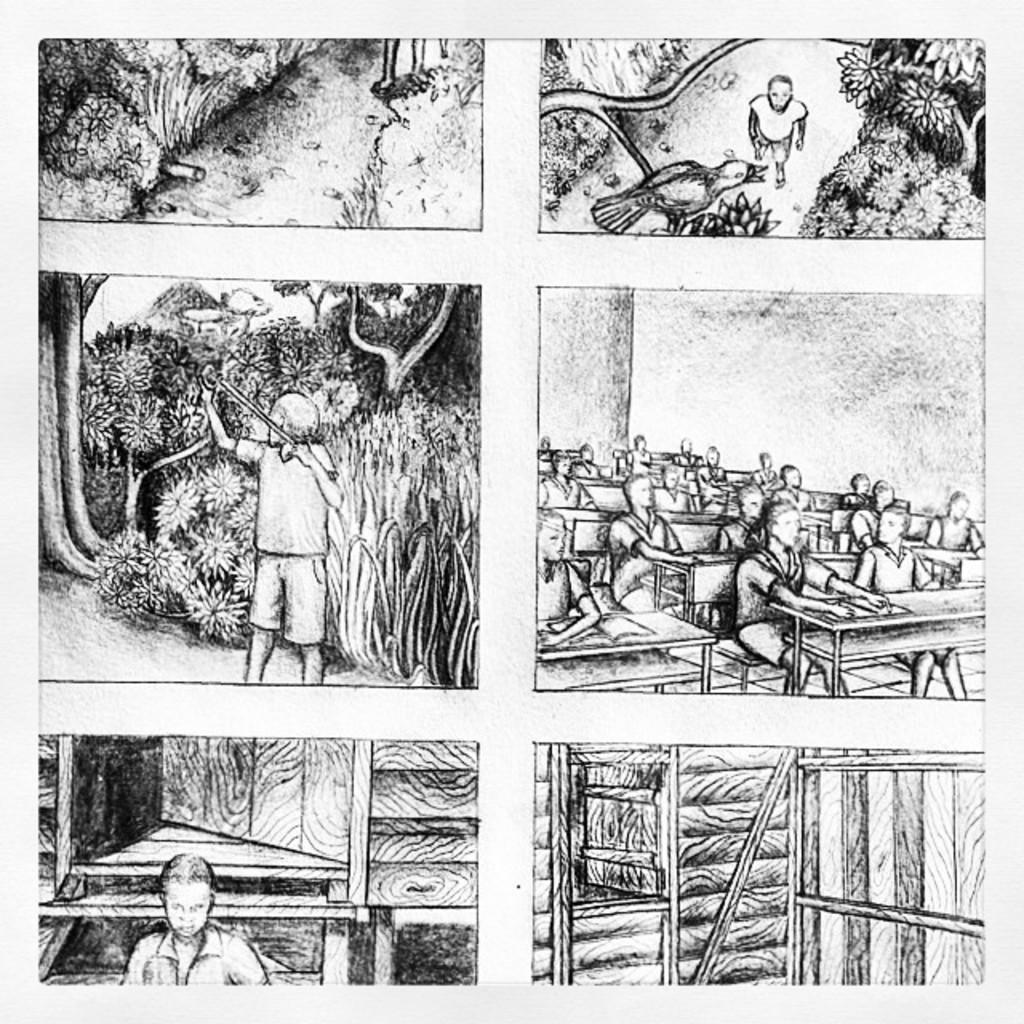Can you describe this image briefly? In this image, we can see few sketches on the white surface. Here we can see few people, trees, plants, bird, few objects. On the right side of the image, we can see a group of people are sitting on the benches. 